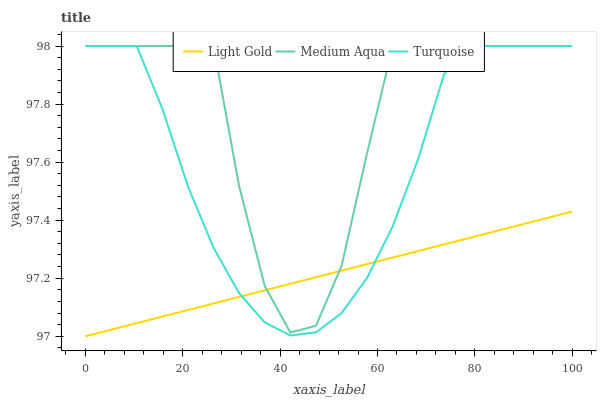Does Light Gold have the minimum area under the curve?
Answer yes or no. Yes. Does Medium Aqua have the maximum area under the curve?
Answer yes or no. Yes. Does Turquoise have the minimum area under the curve?
Answer yes or no. No. Does Turquoise have the maximum area under the curve?
Answer yes or no. No. Is Light Gold the smoothest?
Answer yes or no. Yes. Is Medium Aqua the roughest?
Answer yes or no. Yes. Is Turquoise the smoothest?
Answer yes or no. No. Is Turquoise the roughest?
Answer yes or no. No. Does Turquoise have the lowest value?
Answer yes or no. No. Does Turquoise have the highest value?
Answer yes or no. Yes. Does Light Gold have the highest value?
Answer yes or no. No. Does Medium Aqua intersect Light Gold?
Answer yes or no. Yes. Is Medium Aqua less than Light Gold?
Answer yes or no. No. Is Medium Aqua greater than Light Gold?
Answer yes or no. No. 